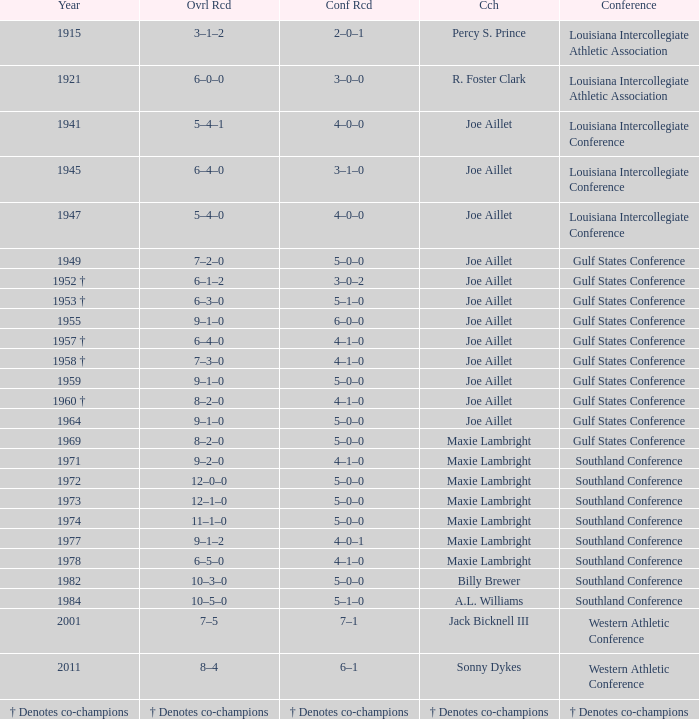What is the conference record for the year of 1971? 4–1–0. 